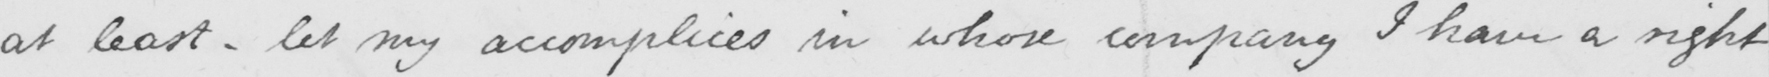Can you tell me what this handwritten text says? at least  _  let my accomplices in whose company I have a right 